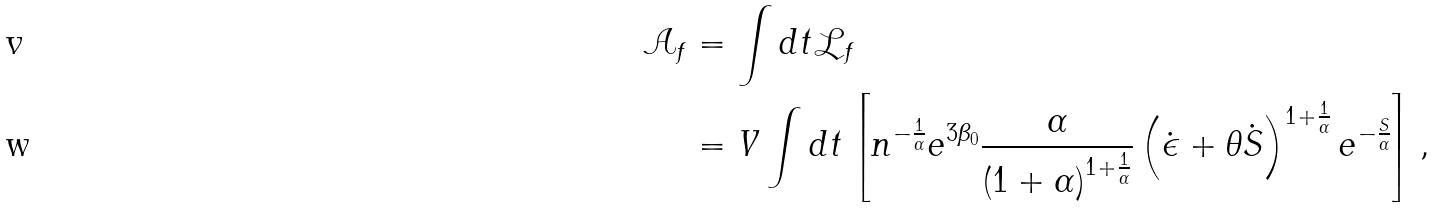Convert formula to latex. <formula><loc_0><loc_0><loc_500><loc_500>\mathcal { A } _ { f } & = \int d t \mathcal { L } _ { f } \\ & = V \int d t \left [ n ^ { - \frac { 1 } { \alpha } } e ^ { 3 \beta _ { 0 } } \frac { \alpha } { \left ( 1 + \alpha \right ) ^ { 1 + \frac { 1 } { \alpha } } } \left ( \dot { \epsilon } + \theta \dot { S } \right ) ^ { 1 + \frac { 1 } { \alpha } } e ^ { - \frac { S } { \alpha } } \right ] ,</formula> 